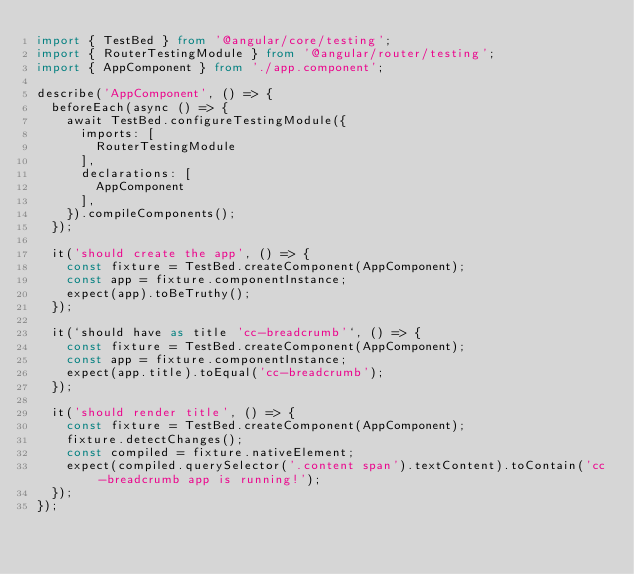Convert code to text. <code><loc_0><loc_0><loc_500><loc_500><_TypeScript_>import { TestBed } from '@angular/core/testing';
import { RouterTestingModule } from '@angular/router/testing';
import { AppComponent } from './app.component';

describe('AppComponent', () => {
  beforeEach(async () => {
    await TestBed.configureTestingModule({
      imports: [
        RouterTestingModule
      ],
      declarations: [
        AppComponent
      ],
    }).compileComponents();
  });

  it('should create the app', () => {
    const fixture = TestBed.createComponent(AppComponent);
    const app = fixture.componentInstance;
    expect(app).toBeTruthy();
  });

  it(`should have as title 'cc-breadcrumb'`, () => {
    const fixture = TestBed.createComponent(AppComponent);
    const app = fixture.componentInstance;
    expect(app.title).toEqual('cc-breadcrumb');
  });

  it('should render title', () => {
    const fixture = TestBed.createComponent(AppComponent);
    fixture.detectChanges();
    const compiled = fixture.nativeElement;
    expect(compiled.querySelector('.content span').textContent).toContain('cc-breadcrumb app is running!');
  });
});
</code> 